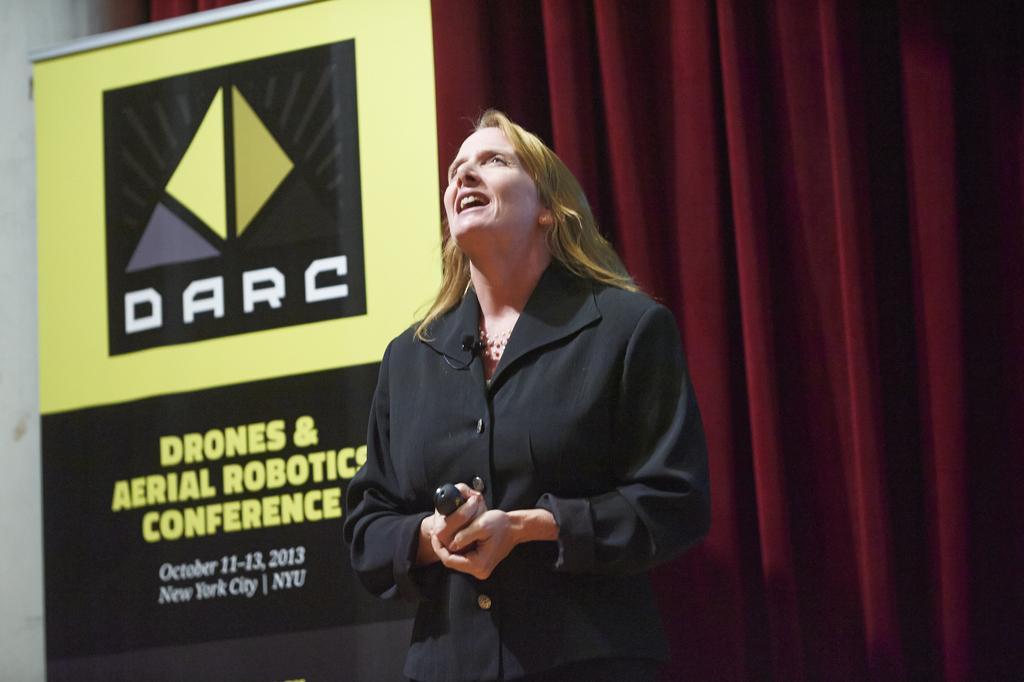Can you describe this image briefly? In this image, we can see a person holding an object and standing. We can also see a board with some text and image. We can also see the curtain. 